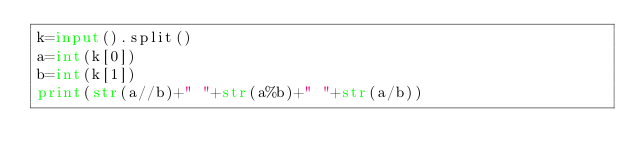Convert code to text. <code><loc_0><loc_0><loc_500><loc_500><_Python_>k=input().split()
a=int(k[0])
b=int(k[1])
print(str(a//b)+" "+str(a%b)+" "+str(a/b))
</code> 